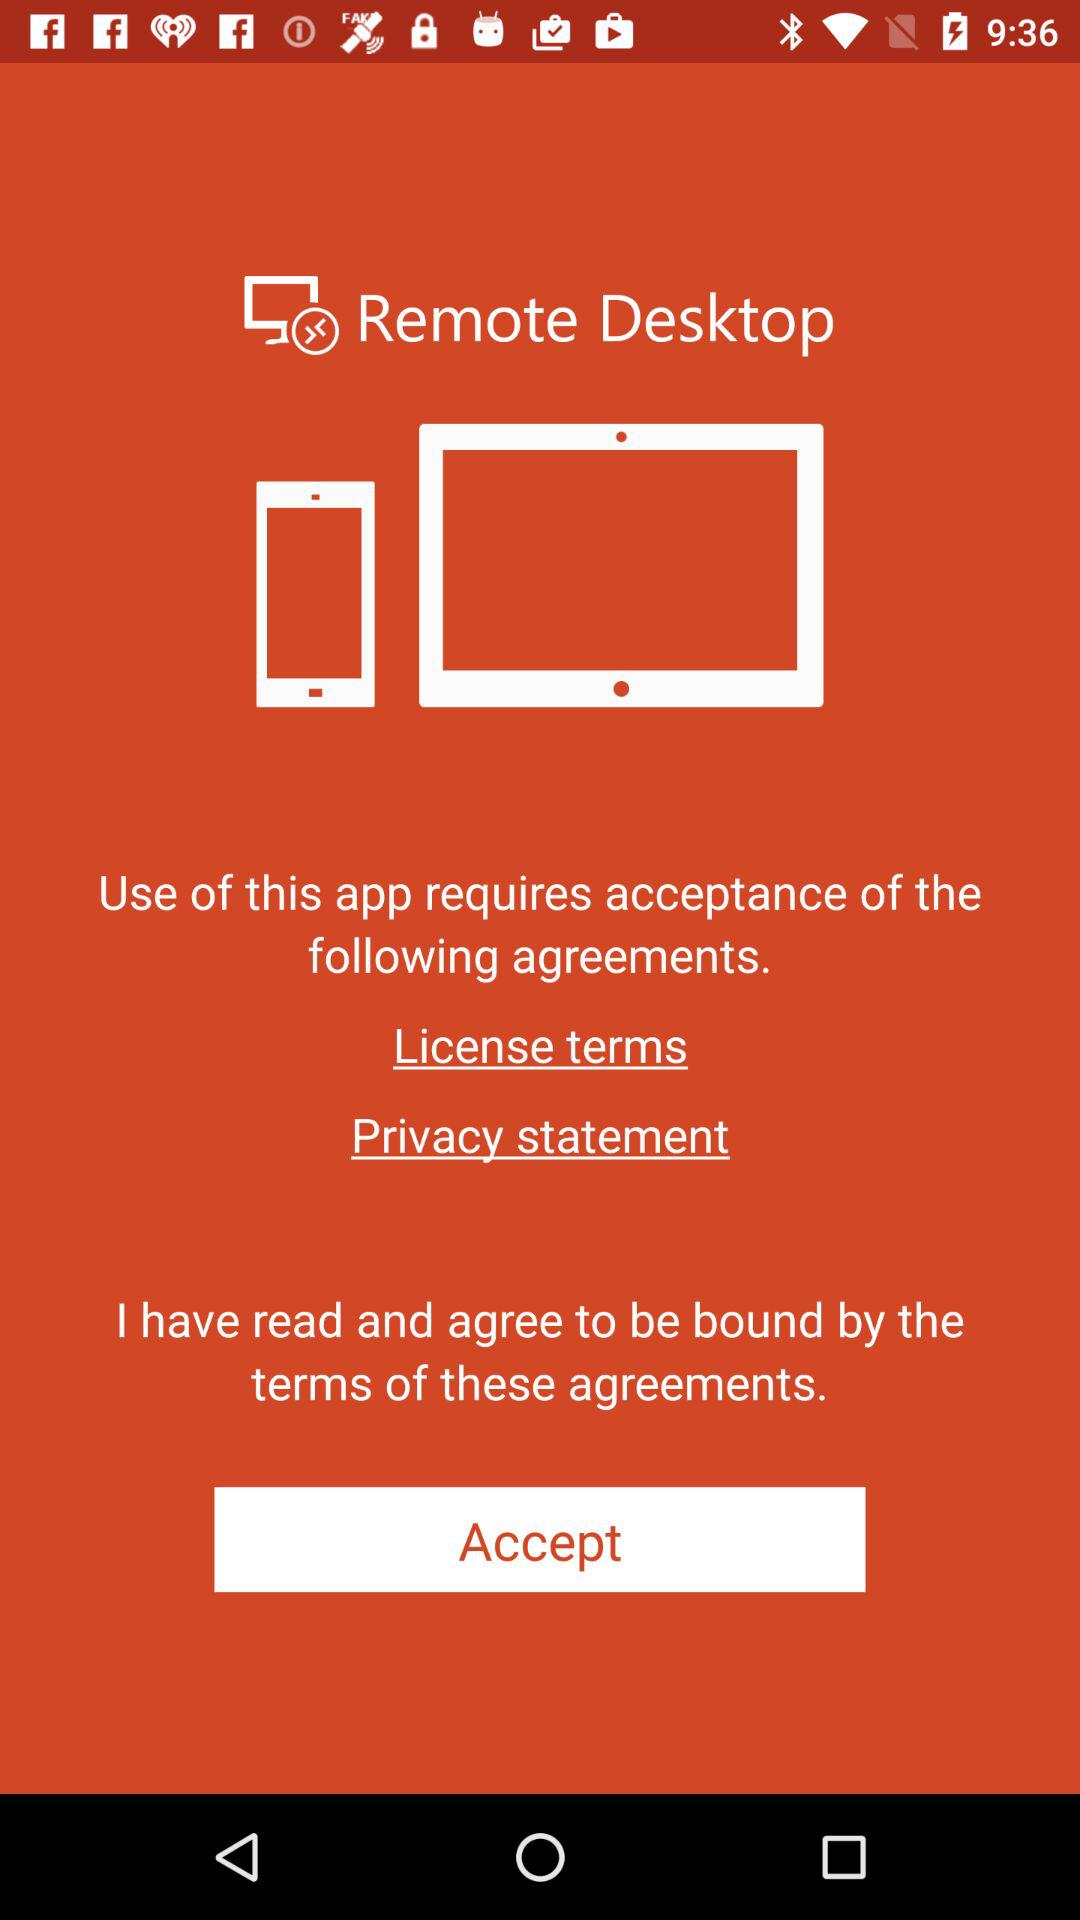How many terms are there to agree to?
Answer the question using a single word or phrase. 2 